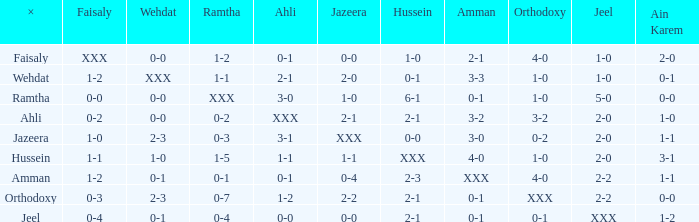What does ramtha mean when jeel's result is 1-0 and hussein's result is 1-0? 1-2. 